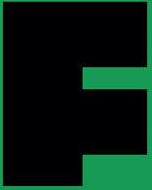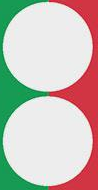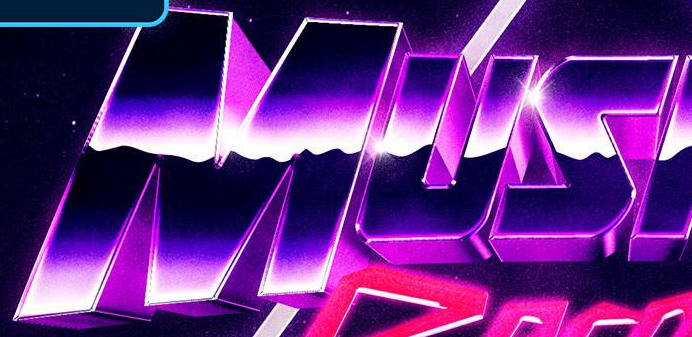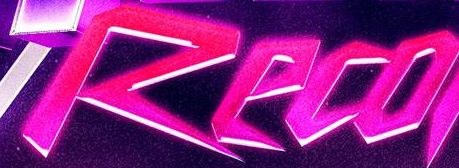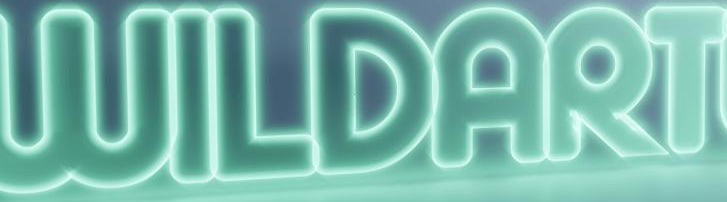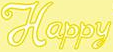Read the text content from these images in order, separated by a semicolon. F; :; MUS; Reco; WILDART; Happy 